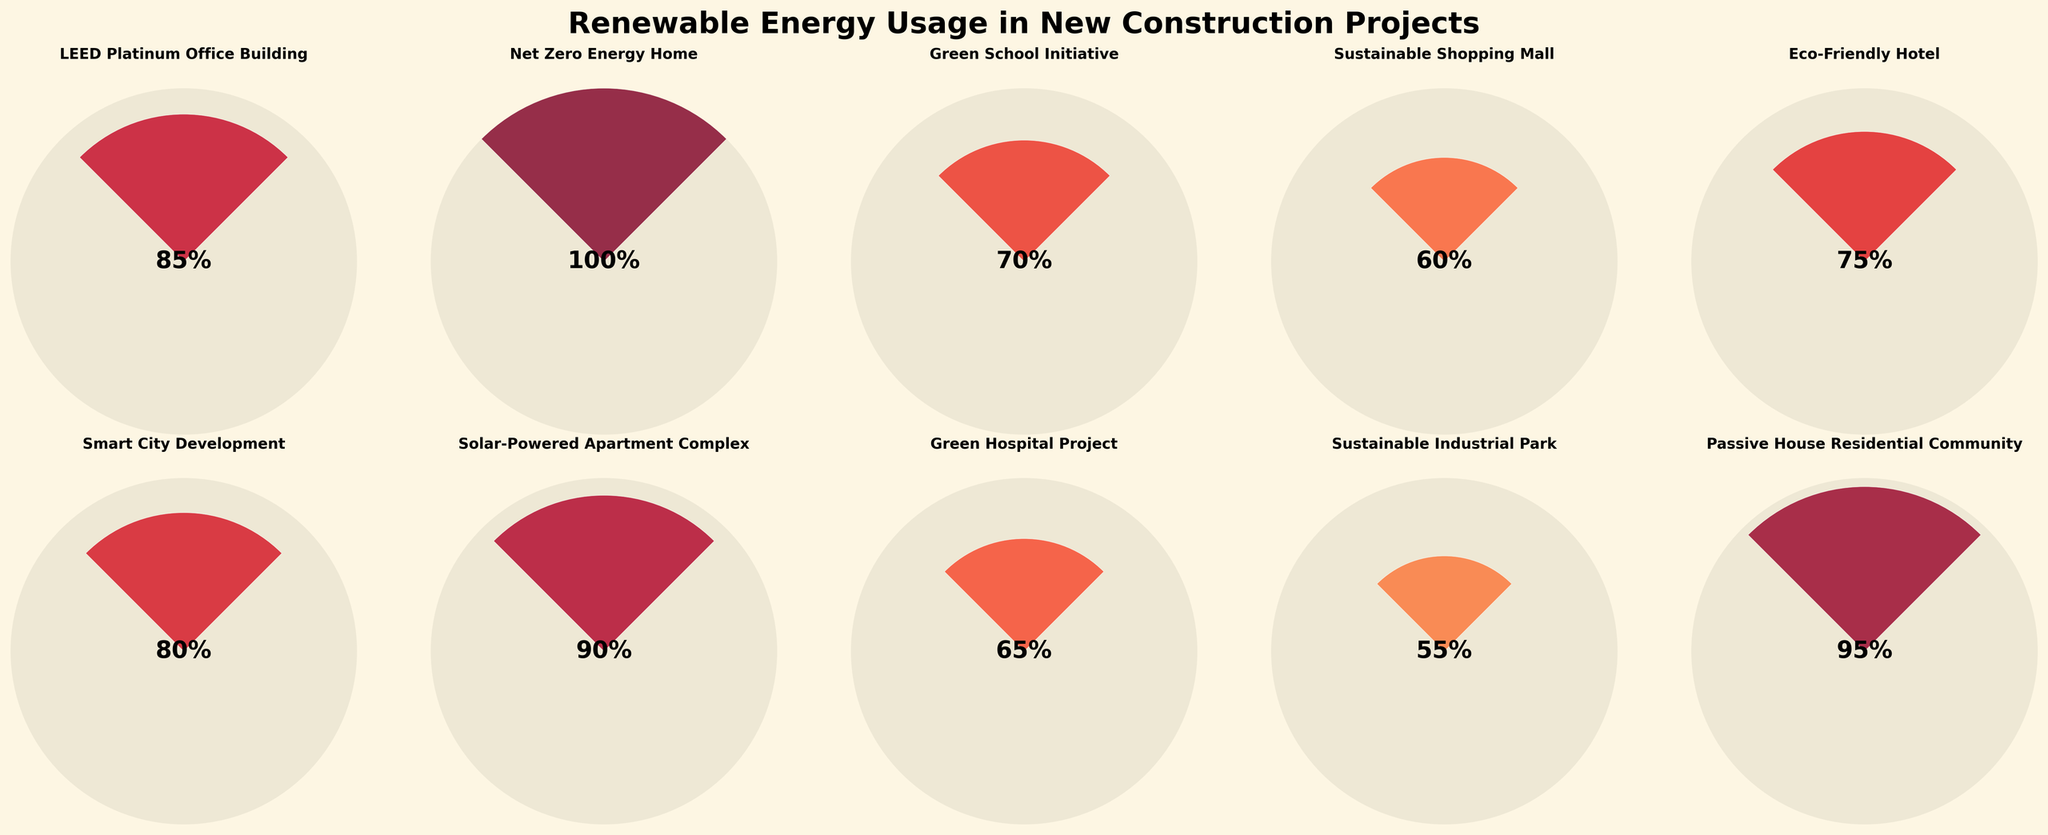What's the highest renewable energy percentage among the projects? The highest renewable energy percentage is shown by the project with the full gauge indicating 100%. Looking at the figure, the "Net Zero Energy Home" project has a gauge with a full 100%.
Answer: Net Zero Energy Home What's the average renewable energy percentage for all projects? To find the average renewable energy percentage, sum up all the values and divide by the number of projects. (85 + 100 + 70 + 60 + 75 + 80 + 90 + 65 + 55 + 95) / 10 = 775 / 10 = 77.5. Therefore, the average is 77.5%.
Answer: 77.5 Which project has the lowest renewable energy percentage? The project with the smallest gauge represents the lowest percentage. The "Sustainable Industrial Park" has the lowest percentage at 55%.
Answer: Sustainable Industrial Park What is the combined renewable energy percentage of the "Green School Initiative" and the "Eco-Friendly Hotel"? The renewable energy percentages for the "Green School Initiative" and the "Eco-Friendly Hotel" are 70% and 75% respectively. Adding these together gives 70 + 75 = 145%.
Answer: 145% How many construction projects have a renewable energy percentage greater than 80%? First, identify the projects with percentages greater than 80%. These are "LEED Platinum Office Building" (85%), "Net Zero Energy Home" (100%), "Smart City Development" (80%), "Solar-Powered Apartment Complex" (90%), and "Passive House Residential Community" (95%). There are 5 such projects.
Answer: 5 Which project falls in the middle of the renewable energy percentage distribution? To find the median, list the percentages in ascending order: 55, 60, 65, 70, 75, 80, 85, 90, 95, 100. The fifth and sixth numbers are 75 and 80; thus, the median is the average of these two values, (75 + 80) / 2 = 77.5. The projects are therefore "Eco-Friendly Hotel" and "Smart City Development".
Answer: Eco-Friendly Hotel, Smart City Development Is there a project with exactly 100% renewable energy usage? If yes, name it. From the figure, the "Net Zero Energy Home" has a 100% gauge indicating full renewable energy usage.
Answer: Net Zero Energy Home How does the renewable energy percentage of the "Green Hospital Project" compare to the "Green School Initiative"? The "Green Hospital Project" has a renewable energy percentage of 65%, while the "Green School Initiative" has 70%. Hence, the "Green School Initiative" has a higher renewable energy percentage by 5%.
Answer: Green School Initiative is higher by 5% Which two projects have renewable energy percentages closest to 80%? Examining the percentages close to 80%, "Smart City Development" is exactly 80% and "LEED Platinum Office Building" is 85%. The closest lower percentage is "Eco-Friendly Hotel" at 75%. Thus, the two closest projects are "Smart City Development" and "LEED Platinum Office Building".
Answer: Smart City Development, LEED Platinum Office Building 